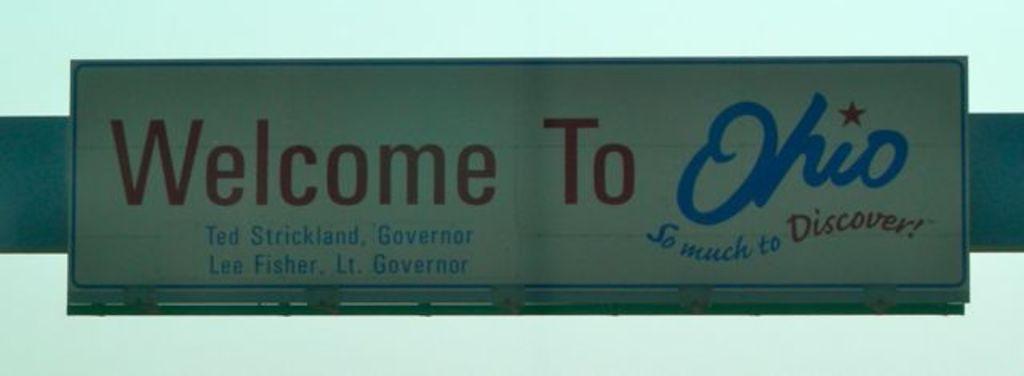Who is the governor?
Your answer should be compact. Ted strickland. 